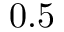<formula> <loc_0><loc_0><loc_500><loc_500>0 . 5</formula> 